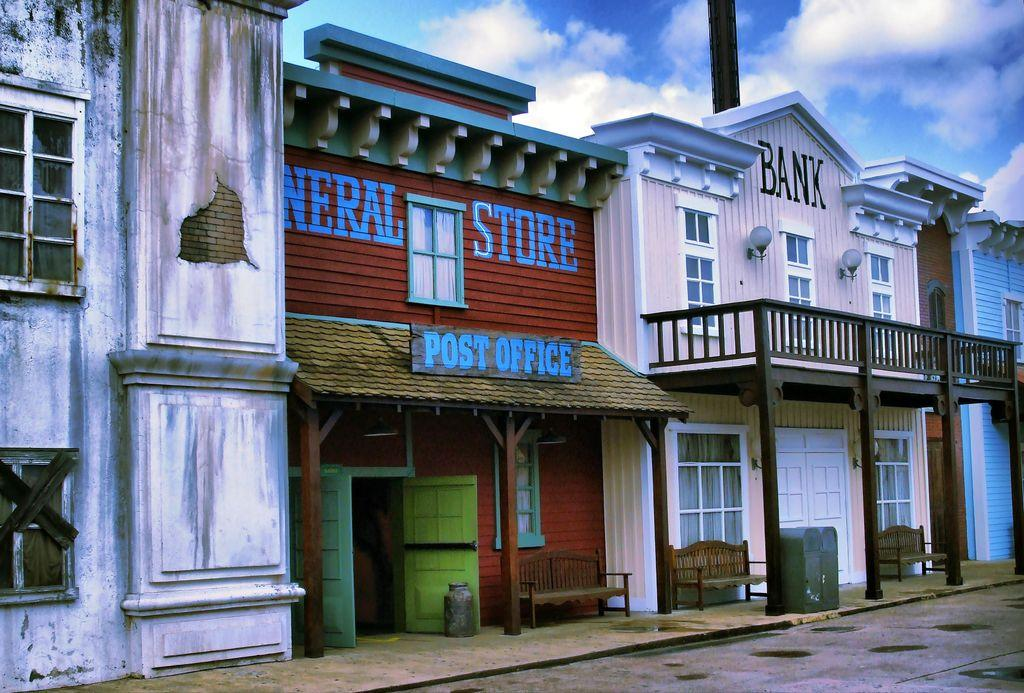What type of structures can be seen in the image? There are buildings in the image. What can be seen in the sky at the top of the image? The sky and clouds are visible at the top of the image. What features are present on the buildings? Windows and doors are present on the buildings. What type of seating is available at the bottom of the image? There are benches at the bottom of the image. What type of chalk is being used by the students in the image? There are no students or chalk present in the image. What type of education is being taught in the image? There is no reference to education or teaching in the image. 